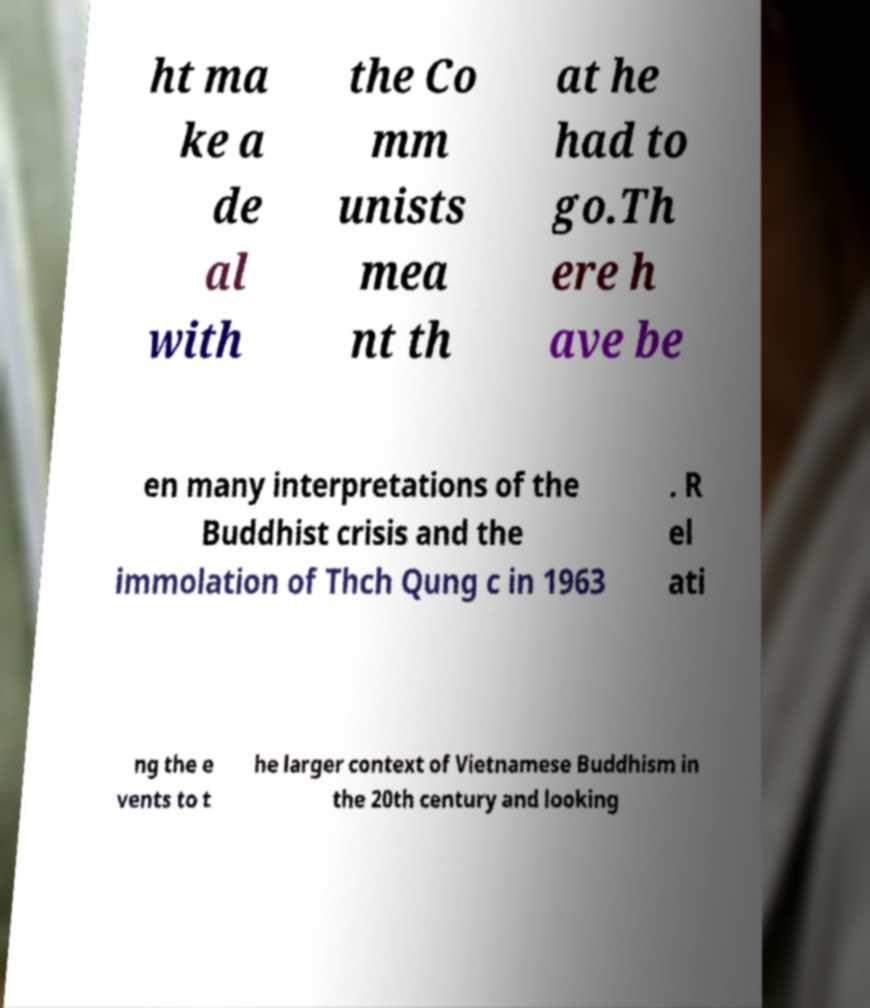What messages or text are displayed in this image? I need them in a readable, typed format. ht ma ke a de al with the Co mm unists mea nt th at he had to go.Th ere h ave be en many interpretations of the Buddhist crisis and the immolation of Thch Qung c in 1963 . R el ati ng the e vents to t he larger context of Vietnamese Buddhism in the 20th century and looking 